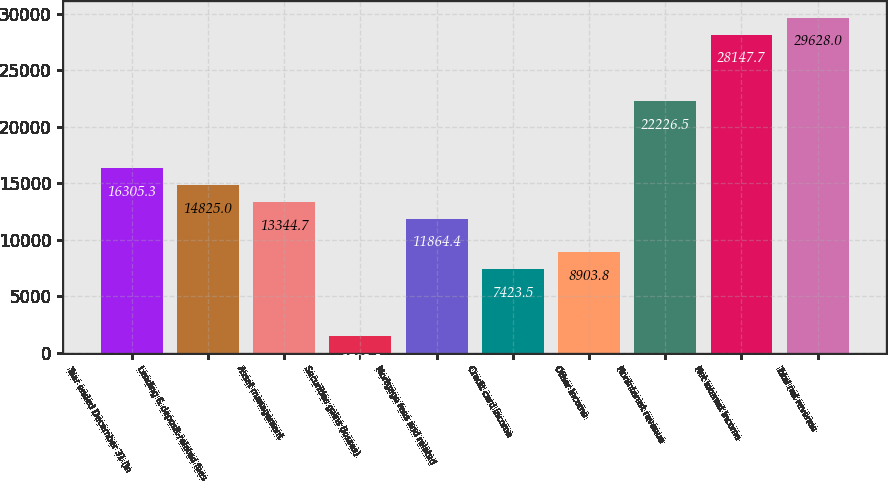<chart> <loc_0><loc_0><loc_500><loc_500><bar_chart><fcel>Year ended December 31 (in<fcel>Lending & deposit-related fees<fcel>Asset management<fcel>Securities gains (losses)<fcel>Mortgage fees and related<fcel>Credit card income<fcel>Other income<fcel>Noninterest revenue<fcel>Net interest income<fcel>Total net revenue<nl><fcel>16305.3<fcel>14825<fcel>13344.7<fcel>1502.3<fcel>11864.4<fcel>7423.5<fcel>8903.8<fcel>22226.5<fcel>28147.7<fcel>29628<nl></chart> 